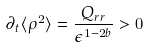Convert formula to latex. <formula><loc_0><loc_0><loc_500><loc_500>\partial _ { t } \langle \rho ^ { 2 } \rangle = \frac { Q _ { r r } } { \epsilon ^ { 1 - 2 b } } > 0</formula> 